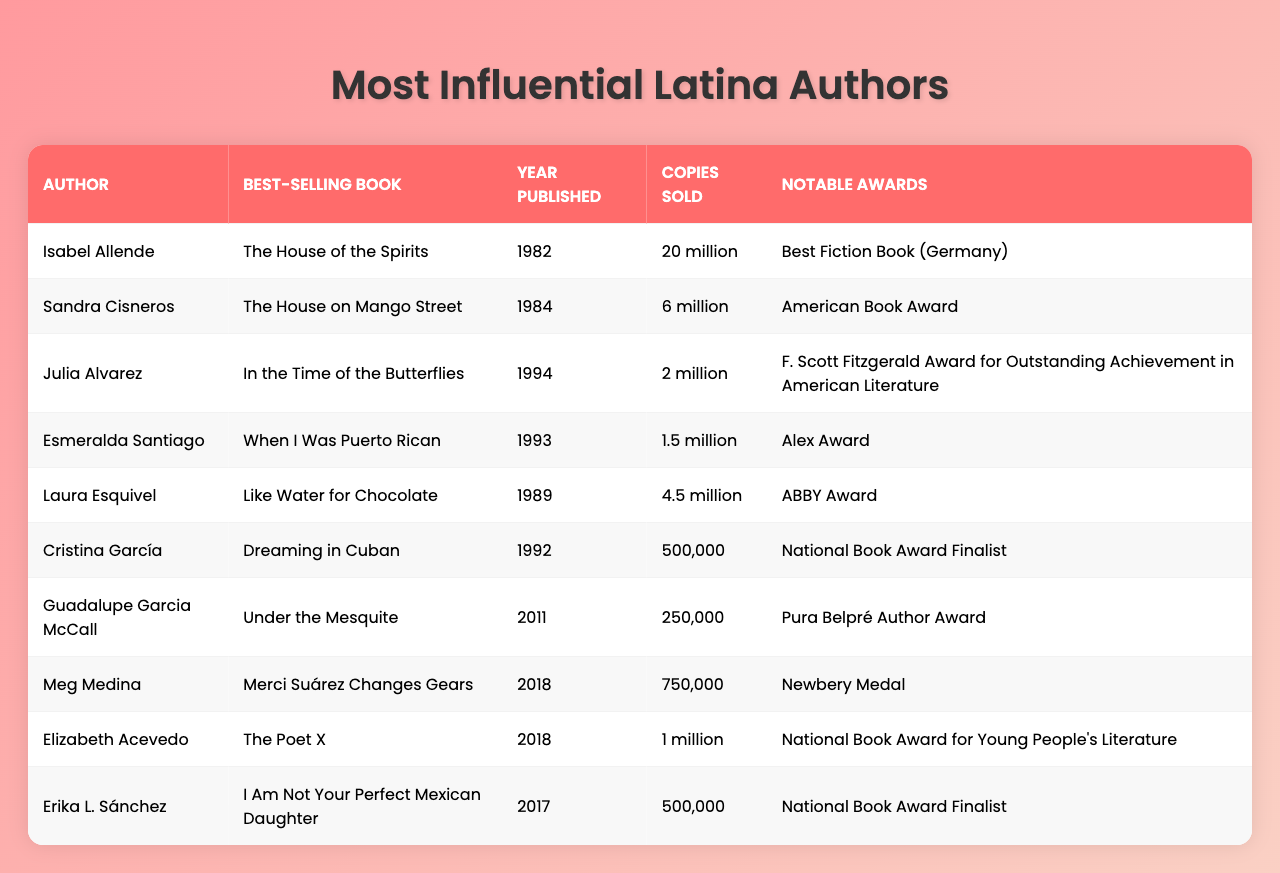What is the best-selling book by Isabel Allende? The table lists Isabel Allende's best-selling book in the second column, which is "The House of the Spirits."
Answer: The House of the Spirits How many copies of "The House on Mango Street" were sold? The table indicates that "The House on Mango Street," written by Sandra Cisneros, sold 6 million copies.
Answer: 6 million Which author won the Newbery Medal? Looking at the notable awards column for each author, Meg Medina is noted as the winner of the Newbery Medal for her book "Merci Suárez Changes Gears."
Answer: Meg Medina What is the year of publication for "When I Was Puerto Rican"? The table shows that "When I Was Puerto Rican" was published in 1993.
Answer: 1993 Which author has the highest number of copies sold? The table reveals that Isabel Allende, with "The House of the Spirits," sold 20 million copies, making her the author with the highest sales.
Answer: Isabel Allende How many authors listed have sold more than 1 million copies? By checking the Copies Sold column, we see that Isabel Allende, Sandra Cisneros, Laura Esquivel, and Elizabeth Acevedo have all sold more than 1 million copies, totaling four authors.
Answer: 4 authors Is "I Am Not Your Perfect Mexican Daughter" a best-selling book? The table indicates that "I Am Not Your Perfect Mexican Daughter" sold 500,000 copies, which may not classify it as "best-selling" but is still a significant amount. Therefore, we can say it's not highly considered a best-seller.
Answer: No What are the notable awards won by Julia Alvarez? The table shows that Julia Alvarez won the "F. Scott Fitzgerald Award for Outstanding Achievement in American Literature."
Answer: F. Scott Fitzgerald Award Calculate the total copies sold by all the authors listed. To find the total sold, we convert the sales figures into numeric values: 20M + 6M + 2M + 1.5M + 4.5M + 0.5M + 0.25M + 0.75M + 1M + 0.5M = 37M. Therefore, the total copies sold is 37 million.
Answer: 37 million Which author has the lowest sales among those listed? Looking at the Copies Sold column, Cristina García's "Dreaming in Cuban" sold the least at 500,000 copies.
Answer: Cristina García 